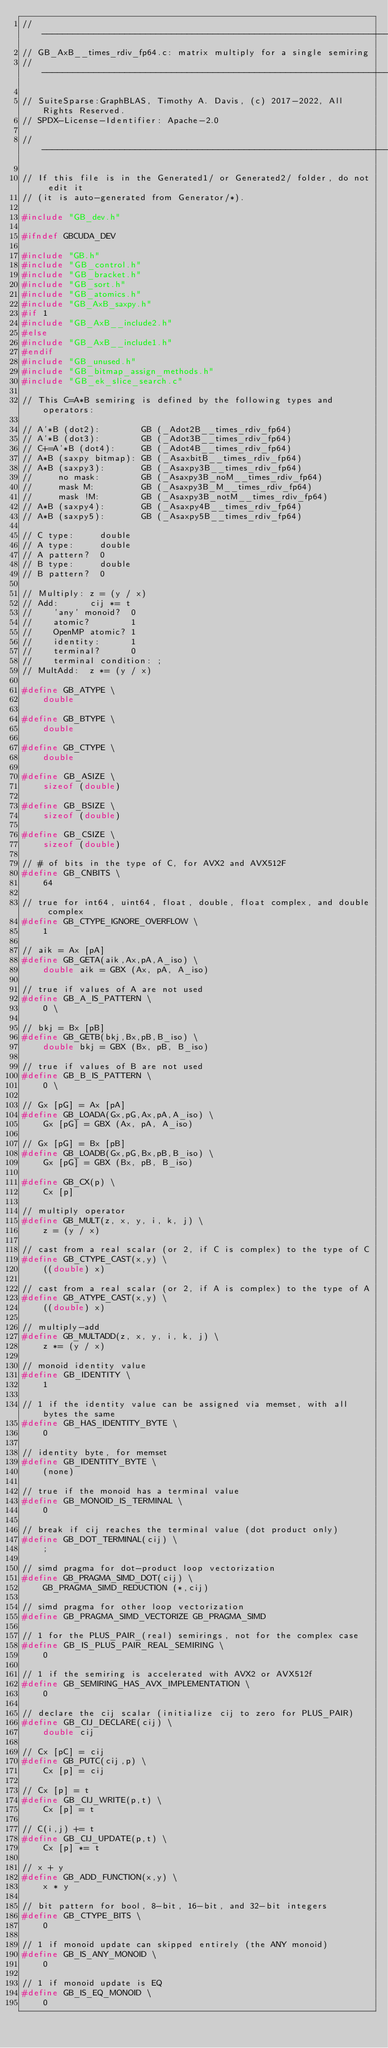<code> <loc_0><loc_0><loc_500><loc_500><_C_>//------------------------------------------------------------------------------
// GB_AxB__times_rdiv_fp64.c: matrix multiply for a single semiring
//------------------------------------------------------------------------------

// SuiteSparse:GraphBLAS, Timothy A. Davis, (c) 2017-2022, All Rights Reserved.
// SPDX-License-Identifier: Apache-2.0

//------------------------------------------------------------------------------

// If this file is in the Generated1/ or Generated2/ folder, do not edit it
// (it is auto-generated from Generator/*).

#include "GB_dev.h"

#ifndef GBCUDA_DEV

#include "GB.h"
#include "GB_control.h"
#include "GB_bracket.h"
#include "GB_sort.h"
#include "GB_atomics.h"
#include "GB_AxB_saxpy.h"
#if 1
#include "GB_AxB__include2.h"
#else
#include "GB_AxB__include1.h"
#endif
#include "GB_unused.h"
#include "GB_bitmap_assign_methods.h"
#include "GB_ek_slice_search.c"

// This C=A*B semiring is defined by the following types and operators:

// A'*B (dot2):        GB (_Adot2B__times_rdiv_fp64)
// A'*B (dot3):        GB (_Adot3B__times_rdiv_fp64)
// C+=A'*B (dot4):     GB (_Adot4B__times_rdiv_fp64)
// A*B (saxpy bitmap): GB (_AsaxbitB__times_rdiv_fp64)
// A*B (saxpy3):       GB (_Asaxpy3B__times_rdiv_fp64)
//     no mask:        GB (_Asaxpy3B_noM__times_rdiv_fp64)
//     mask M:         GB (_Asaxpy3B_M__times_rdiv_fp64)
//     mask !M:        GB (_Asaxpy3B_notM__times_rdiv_fp64)
// A*B (saxpy4):       GB (_Asaxpy4B__times_rdiv_fp64)
// A*B (saxpy5):       GB (_Asaxpy5B__times_rdiv_fp64)

// C type:     double
// A type:     double
// A pattern?  0
// B type:     double
// B pattern?  0

// Multiply: z = (y / x)
// Add:      cij *= t
//    'any' monoid?  0
//    atomic?        1
//    OpenMP atomic? 1
//    identity:      1
//    terminal?      0
//    terminal condition: ;
// MultAdd:  z *= (y / x)

#define GB_ATYPE \
    double

#define GB_BTYPE \
    double

#define GB_CTYPE \
    double

#define GB_ASIZE \
    sizeof (double)

#define GB_BSIZE \
    sizeof (double) 

#define GB_CSIZE \
    sizeof (double)

// # of bits in the type of C, for AVX2 and AVX512F
#define GB_CNBITS \
    64

// true for int64, uint64, float, double, float complex, and double complex 
#define GB_CTYPE_IGNORE_OVERFLOW \
    1

// aik = Ax [pA]
#define GB_GETA(aik,Ax,pA,A_iso) \
    double aik = GBX (Ax, pA, A_iso)

// true if values of A are not used
#define GB_A_IS_PATTERN \
    0 \

// bkj = Bx [pB]
#define GB_GETB(bkj,Bx,pB,B_iso) \
    double bkj = GBX (Bx, pB, B_iso)

// true if values of B are not used
#define GB_B_IS_PATTERN \
    0 \

// Gx [pG] = Ax [pA]
#define GB_LOADA(Gx,pG,Ax,pA,A_iso) \
    Gx [pG] = GBX (Ax, pA, A_iso)

// Gx [pG] = Bx [pB]
#define GB_LOADB(Gx,pG,Bx,pB,B_iso) \
    Gx [pG] = GBX (Bx, pB, B_iso)

#define GB_CX(p) \
    Cx [p]

// multiply operator
#define GB_MULT(z, x, y, i, k, j) \
    z = (y / x)

// cast from a real scalar (or 2, if C is complex) to the type of C
#define GB_CTYPE_CAST(x,y) \
    ((double) x)

// cast from a real scalar (or 2, if A is complex) to the type of A
#define GB_ATYPE_CAST(x,y) \
    ((double) x)

// multiply-add
#define GB_MULTADD(z, x, y, i, k, j) \
    z *= (y / x)

// monoid identity value
#define GB_IDENTITY \
    1

// 1 if the identity value can be assigned via memset, with all bytes the same
#define GB_HAS_IDENTITY_BYTE \
    0

// identity byte, for memset
#define GB_IDENTITY_BYTE \
    (none)

// true if the monoid has a terminal value
#define GB_MONOID_IS_TERMINAL \
    0

// break if cij reaches the terminal value (dot product only)
#define GB_DOT_TERMINAL(cij) \
    ;

// simd pragma for dot-product loop vectorization
#define GB_PRAGMA_SIMD_DOT(cij) \
    GB_PRAGMA_SIMD_REDUCTION (*,cij)

// simd pragma for other loop vectorization
#define GB_PRAGMA_SIMD_VECTORIZE GB_PRAGMA_SIMD

// 1 for the PLUS_PAIR_(real) semirings, not for the complex case
#define GB_IS_PLUS_PAIR_REAL_SEMIRING \
    0

// 1 if the semiring is accelerated with AVX2 or AVX512f
#define GB_SEMIRING_HAS_AVX_IMPLEMENTATION \
    0

// declare the cij scalar (initialize cij to zero for PLUS_PAIR)
#define GB_CIJ_DECLARE(cij) \
    double cij

// Cx [pC] = cij
#define GB_PUTC(cij,p) \
    Cx [p] = cij

// Cx [p] = t
#define GB_CIJ_WRITE(p,t) \
    Cx [p] = t

// C(i,j) += t
#define GB_CIJ_UPDATE(p,t) \
    Cx [p] *= t

// x + y
#define GB_ADD_FUNCTION(x,y) \
    x * y

// bit pattern for bool, 8-bit, 16-bit, and 32-bit integers
#define GB_CTYPE_BITS \
    0

// 1 if monoid update can skipped entirely (the ANY monoid)
#define GB_IS_ANY_MONOID \
    0

// 1 if monoid update is EQ
#define GB_IS_EQ_MONOID \
    0
</code> 